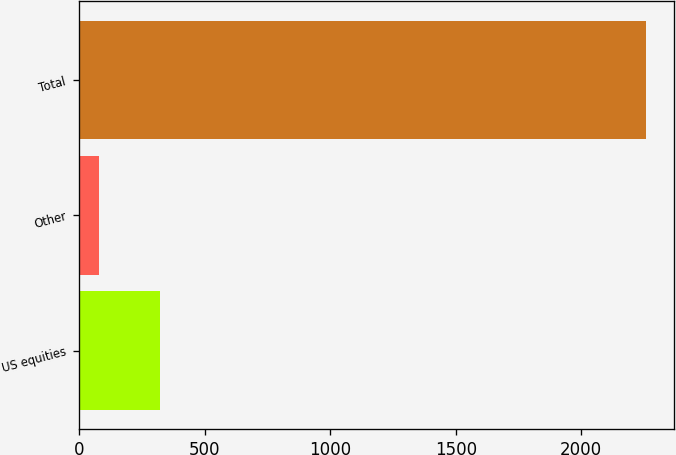<chart> <loc_0><loc_0><loc_500><loc_500><bar_chart><fcel>US equities<fcel>Other<fcel>Total<nl><fcel>320<fcel>78<fcel>2257<nl></chart> 